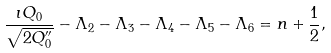Convert formula to latex. <formula><loc_0><loc_0><loc_500><loc_500>\frac { \imath Q _ { 0 } } { \sqrt { 2 Q _ { 0 } ^ { \prime \prime } } } - \Lambda _ { 2 } - \Lambda _ { 3 } - \Lambda _ { 4 } - \Lambda _ { 5 } - \Lambda _ { 6 } = n + \frac { 1 } { 2 } ,</formula> 